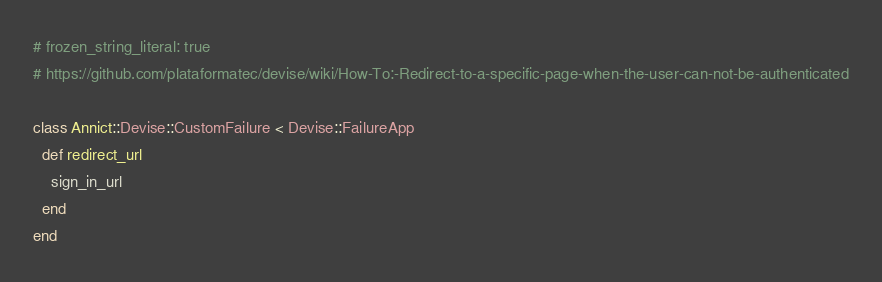Convert code to text. <code><loc_0><loc_0><loc_500><loc_500><_Ruby_># frozen_string_literal: true
# https://github.com/plataformatec/devise/wiki/How-To:-Redirect-to-a-specific-page-when-the-user-can-not-be-authenticated

class Annict::Devise::CustomFailure < Devise::FailureApp
  def redirect_url
    sign_in_url
  end
end
</code> 